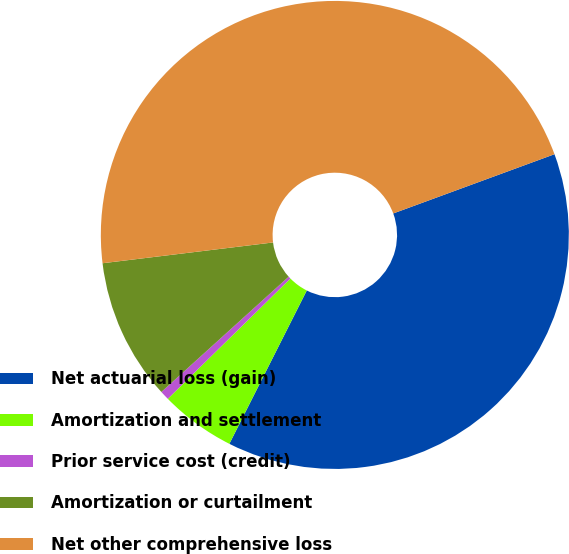Convert chart. <chart><loc_0><loc_0><loc_500><loc_500><pie_chart><fcel>Net actuarial loss (gain)<fcel>Amortization and settlement<fcel>Prior service cost (credit)<fcel>Amortization or curtailment<fcel>Net other comprehensive loss<nl><fcel>38.05%<fcel>5.21%<fcel>0.64%<fcel>9.78%<fcel>46.33%<nl></chart> 